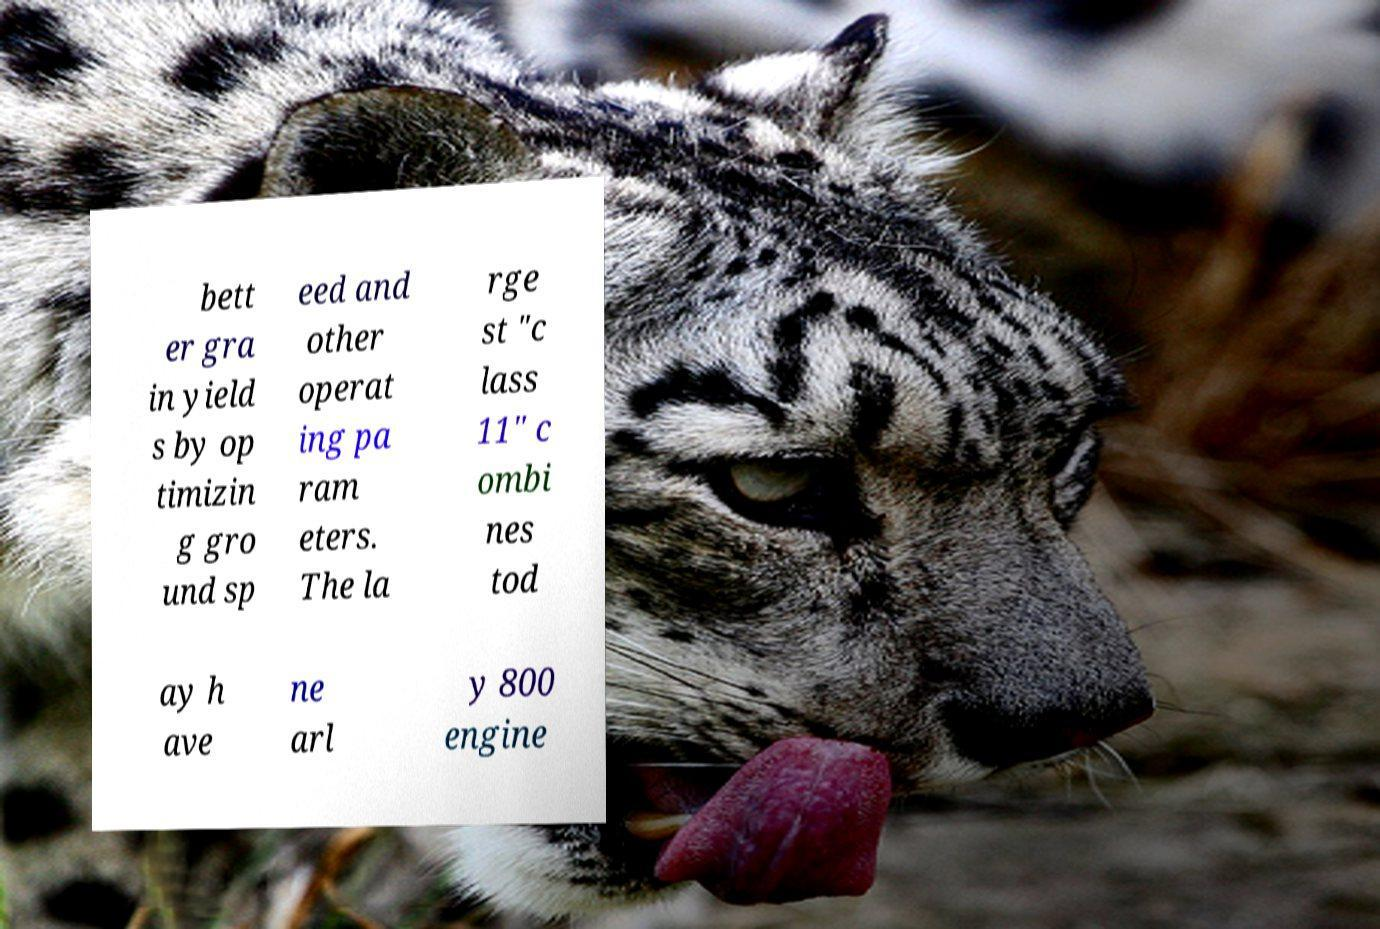For documentation purposes, I need the text within this image transcribed. Could you provide that? bett er gra in yield s by op timizin g gro und sp eed and other operat ing pa ram eters. The la rge st "c lass 11" c ombi nes tod ay h ave ne arl y 800 engine 